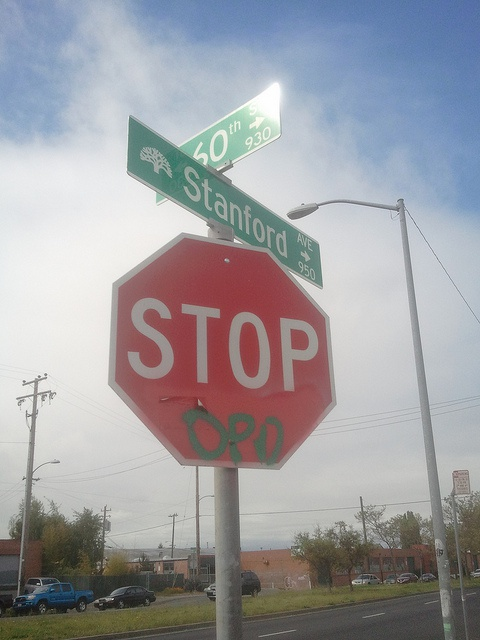Describe the objects in this image and their specific colors. I can see stop sign in darkgray, brown, and gray tones, truck in darkgray, black, blue, darkblue, and gray tones, car in darkgray, black, gray, and purple tones, truck in darkgray, black, and gray tones, and car in darkgray, black, gray, and purple tones in this image. 